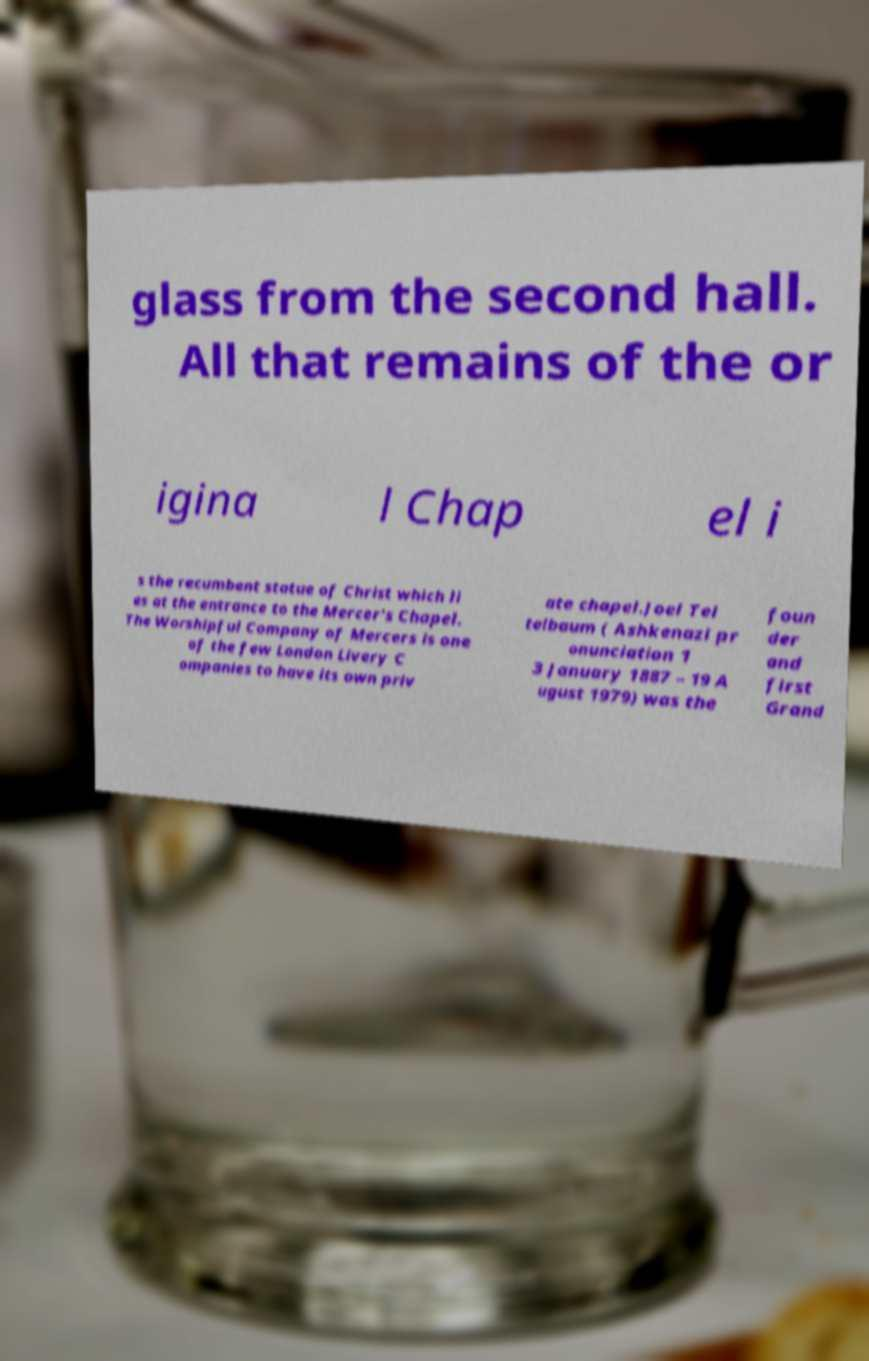There's text embedded in this image that I need extracted. Can you transcribe it verbatim? glass from the second hall. All that remains of the or igina l Chap el i s the recumbent statue of Christ which li es at the entrance to the Mercer's Chapel. The Worshipful Company of Mercers is one of the few London Livery C ompanies to have its own priv ate chapel.Joel Tei telbaum ( Ashkenazi pr onunciation 1 3 January 1887 – 19 A ugust 1979) was the foun der and first Grand 